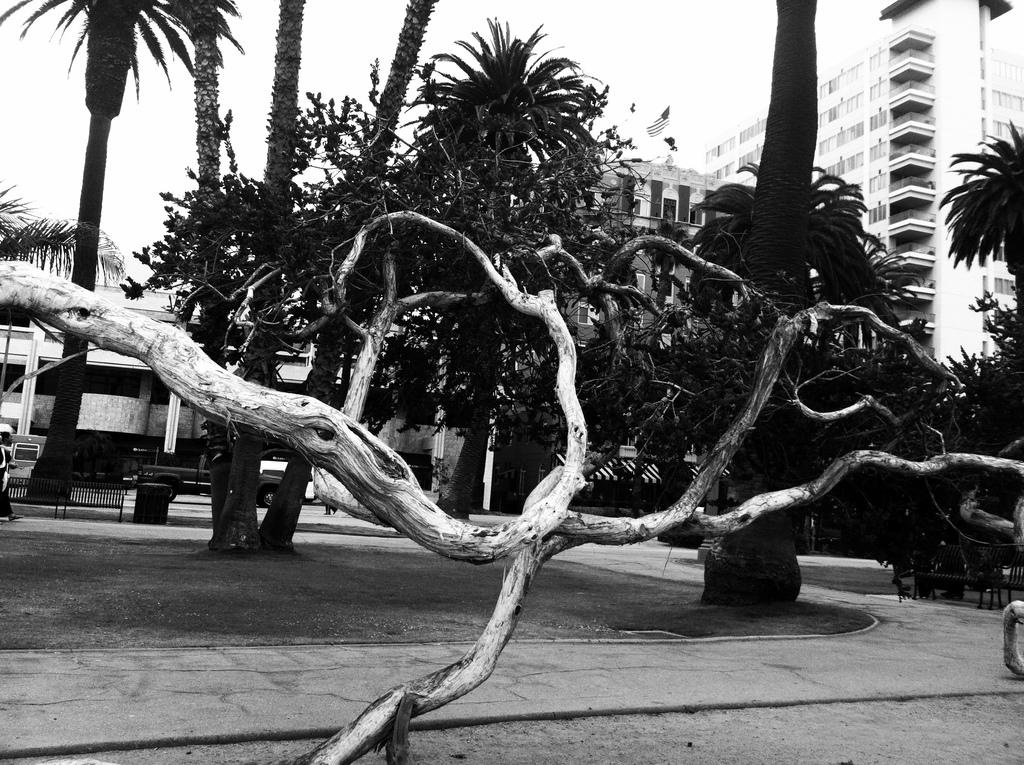What type of natural elements can be seen in the image? There are trees in the image. What type of man-made structures are present in the image? There are buildings in the image. What other objects can be seen in the image besides trees and buildings? There are other objects in the image. What can be seen in the background of the image? The sky is visible in the background of the image. What is the color scheme of the image? The image is black and white in color. How many girls are working in the gold mine in the image? There is no gold mine or girls present in the image; it features trees, buildings, and other objects in a black and white color scheme. 